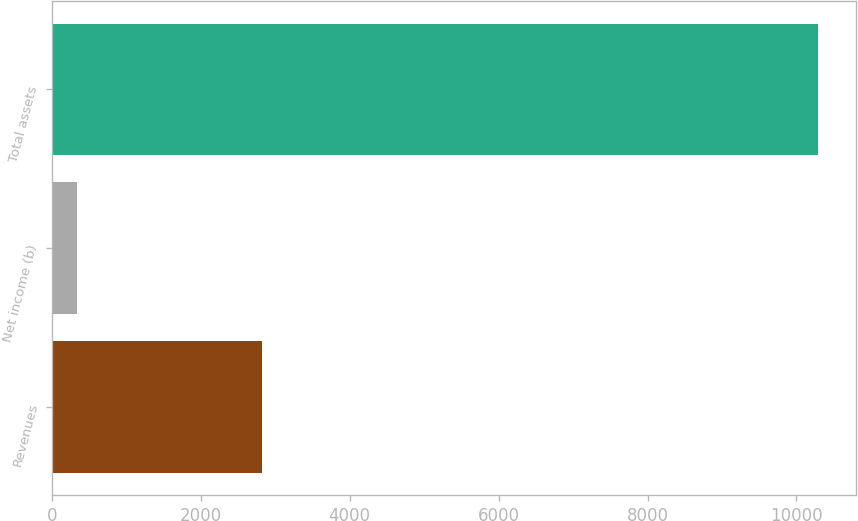Convert chart. <chart><loc_0><loc_0><loc_500><loc_500><bar_chart><fcel>Revenues<fcel>Net income (b)<fcel>Total assets<nl><fcel>2823<fcel>343<fcel>10290<nl></chart> 